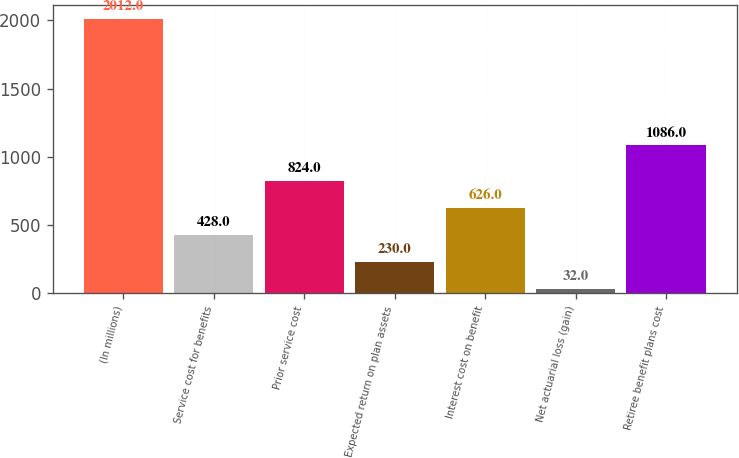Convert chart to OTSL. <chart><loc_0><loc_0><loc_500><loc_500><bar_chart><fcel>(In millions)<fcel>Service cost for benefits<fcel>Prior service cost<fcel>Expected return on plan assets<fcel>Interest cost on benefit<fcel>Net actuarial loss (gain)<fcel>Retiree benefit plans cost<nl><fcel>2012<fcel>428<fcel>824<fcel>230<fcel>626<fcel>32<fcel>1086<nl></chart> 